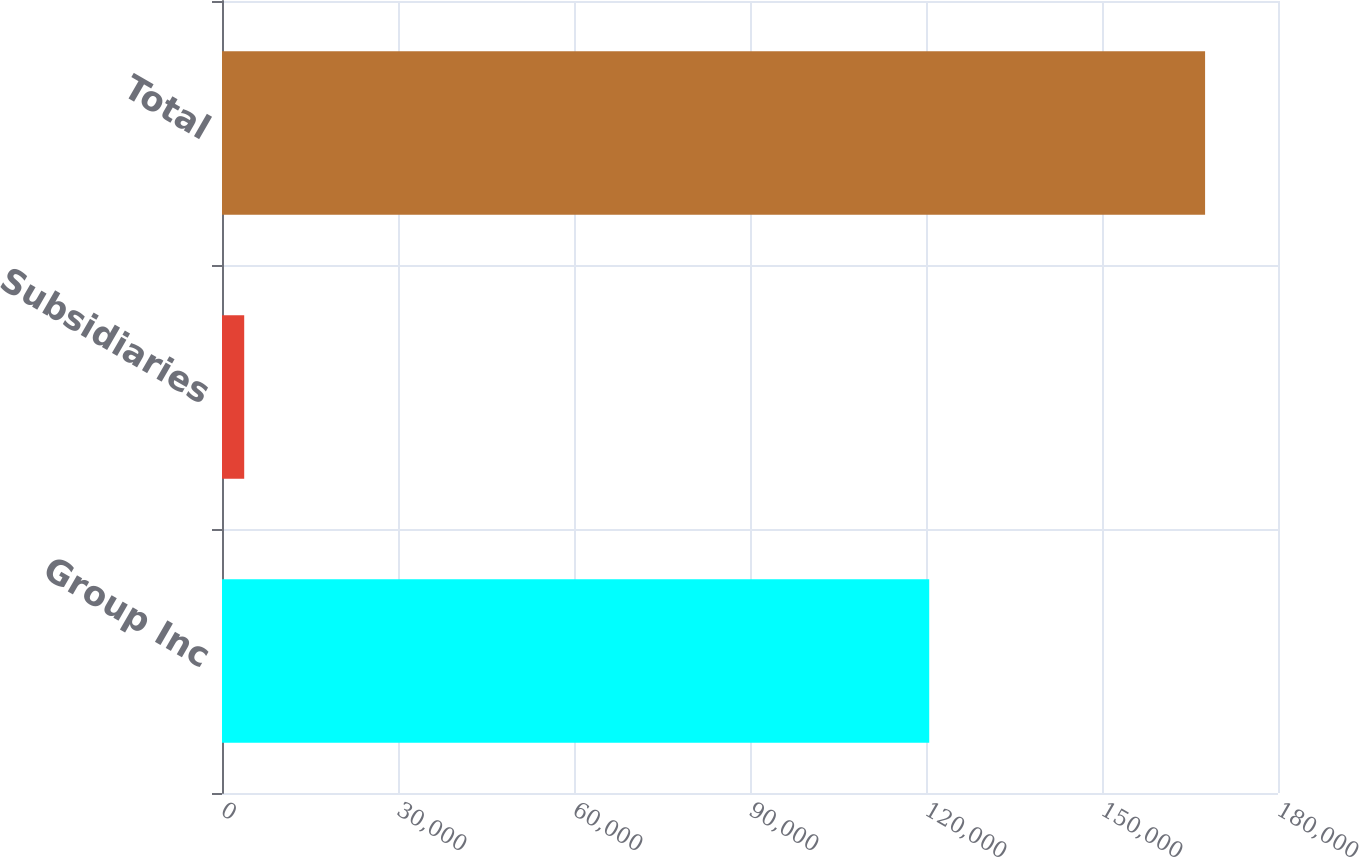<chart> <loc_0><loc_0><loc_500><loc_500><bar_chart><fcel>Group Inc<fcel>Subsidiaries<fcel>Total<nl><fcel>120549<fcel>3785<fcel>167571<nl></chart> 